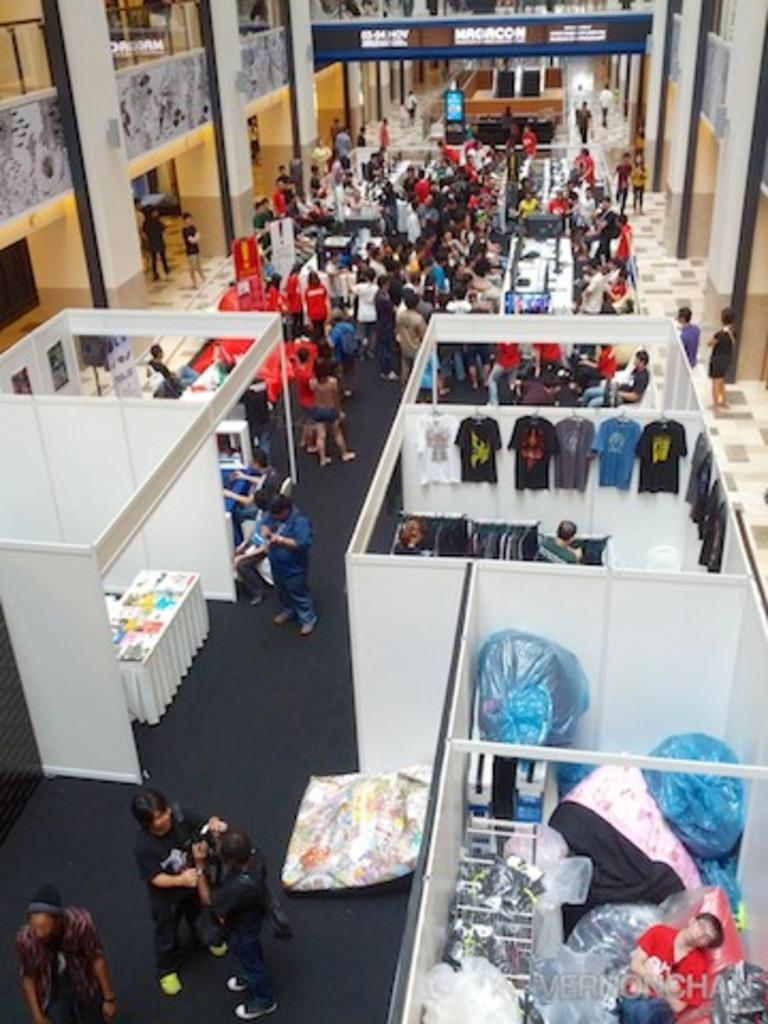What can be seen in the image in terms of commercial establishments? There are many stores in the image. What is the presence of people like in the image? There are many people standing on the floor in the image. What architectural features can be seen in the background of the image? There are pillars in the background of the image. What type of decorations are present on the walls in the background of the image? There are walls with posters in the background of the image. Can you see any veils being worn by the people in the image? There is no mention of veils in the provided facts, and therefore we cannot determine if any are present in the image. How many men are visible in the image? The provided facts do not specify the gender of the people in the image, so we cannot determine the number of men present. Is there any milk being served or consumed in the image? There is no mention of milk in the provided facts, and therefore we cannot determine if any is present in the image. 